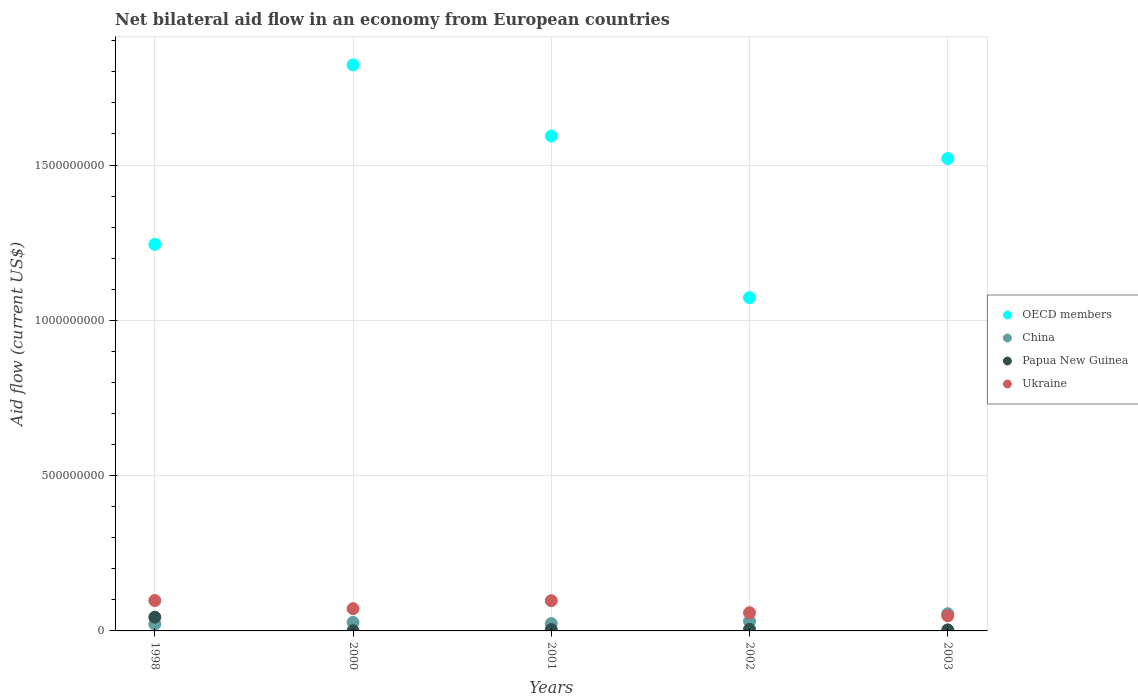How many different coloured dotlines are there?
Keep it short and to the point. 4. What is the net bilateral aid flow in Papua New Guinea in 2003?
Your response must be concise. 3.27e+06. Across all years, what is the maximum net bilateral aid flow in Papua New Guinea?
Provide a succinct answer. 4.43e+07. Across all years, what is the minimum net bilateral aid flow in Papua New Guinea?
Ensure brevity in your answer.  5.70e+05. In which year was the net bilateral aid flow in Papua New Guinea maximum?
Ensure brevity in your answer.  1998. In which year was the net bilateral aid flow in Papua New Guinea minimum?
Provide a succinct answer. 2000. What is the total net bilateral aid flow in OECD members in the graph?
Offer a very short reply. 7.25e+09. What is the difference between the net bilateral aid flow in Papua New Guinea in 2000 and that in 2001?
Your answer should be very brief. -3.73e+06. What is the difference between the net bilateral aid flow in Papua New Guinea in 1998 and the net bilateral aid flow in China in 2003?
Your answer should be compact. -1.11e+07. What is the average net bilateral aid flow in Papua New Guinea per year?
Your answer should be very brief. 1.15e+07. In the year 1998, what is the difference between the net bilateral aid flow in Ukraine and net bilateral aid flow in Papua New Guinea?
Ensure brevity in your answer.  5.36e+07. In how many years, is the net bilateral aid flow in China greater than 1600000000 US$?
Provide a succinct answer. 0. What is the ratio of the net bilateral aid flow in Papua New Guinea in 2000 to that in 2003?
Keep it short and to the point. 0.17. Is the net bilateral aid flow in OECD members in 1998 less than that in 2002?
Keep it short and to the point. No. Is the difference between the net bilateral aid flow in Ukraine in 2000 and 2003 greater than the difference between the net bilateral aid flow in Papua New Guinea in 2000 and 2003?
Provide a succinct answer. Yes. What is the difference between the highest and the lowest net bilateral aid flow in Papua New Guinea?
Your answer should be compact. 4.37e+07. In how many years, is the net bilateral aid flow in Papua New Guinea greater than the average net bilateral aid flow in Papua New Guinea taken over all years?
Make the answer very short. 1. Is it the case that in every year, the sum of the net bilateral aid flow in China and net bilateral aid flow in Ukraine  is greater than the sum of net bilateral aid flow in Papua New Guinea and net bilateral aid flow in OECD members?
Ensure brevity in your answer.  Yes. Is it the case that in every year, the sum of the net bilateral aid flow in OECD members and net bilateral aid flow in Ukraine  is greater than the net bilateral aid flow in China?
Provide a short and direct response. Yes. Does the net bilateral aid flow in Ukraine monotonically increase over the years?
Provide a succinct answer. No. Is the net bilateral aid flow in Ukraine strictly less than the net bilateral aid flow in Papua New Guinea over the years?
Provide a short and direct response. No. How many dotlines are there?
Provide a succinct answer. 4. What is the difference between two consecutive major ticks on the Y-axis?
Provide a short and direct response. 5.00e+08. Are the values on the major ticks of Y-axis written in scientific E-notation?
Give a very brief answer. No. Does the graph contain any zero values?
Your answer should be compact. No. Does the graph contain grids?
Your answer should be compact. Yes. How are the legend labels stacked?
Give a very brief answer. Vertical. What is the title of the graph?
Give a very brief answer. Net bilateral aid flow in an economy from European countries. What is the Aid flow (current US$) of OECD members in 1998?
Keep it short and to the point. 1.24e+09. What is the Aid flow (current US$) in China in 1998?
Ensure brevity in your answer.  2.17e+07. What is the Aid flow (current US$) of Papua New Guinea in 1998?
Offer a very short reply. 4.43e+07. What is the Aid flow (current US$) in Ukraine in 1998?
Make the answer very short. 9.78e+07. What is the Aid flow (current US$) in OECD members in 2000?
Provide a succinct answer. 1.82e+09. What is the Aid flow (current US$) of China in 2000?
Keep it short and to the point. 2.74e+07. What is the Aid flow (current US$) in Papua New Guinea in 2000?
Offer a very short reply. 5.70e+05. What is the Aid flow (current US$) of Ukraine in 2000?
Offer a terse response. 7.16e+07. What is the Aid flow (current US$) in OECD members in 2001?
Your answer should be very brief. 1.59e+09. What is the Aid flow (current US$) of China in 2001?
Provide a succinct answer. 2.36e+07. What is the Aid flow (current US$) in Papua New Guinea in 2001?
Keep it short and to the point. 4.30e+06. What is the Aid flow (current US$) in Ukraine in 2001?
Ensure brevity in your answer.  9.74e+07. What is the Aid flow (current US$) in OECD members in 2002?
Make the answer very short. 1.07e+09. What is the Aid flow (current US$) in China in 2002?
Offer a terse response. 3.11e+07. What is the Aid flow (current US$) of Papua New Guinea in 2002?
Provide a succinct answer. 4.86e+06. What is the Aid flow (current US$) of Ukraine in 2002?
Provide a succinct answer. 5.85e+07. What is the Aid flow (current US$) in OECD members in 2003?
Your answer should be compact. 1.52e+09. What is the Aid flow (current US$) in China in 2003?
Provide a short and direct response. 5.54e+07. What is the Aid flow (current US$) in Papua New Guinea in 2003?
Provide a succinct answer. 3.27e+06. What is the Aid flow (current US$) in Ukraine in 2003?
Ensure brevity in your answer.  4.86e+07. Across all years, what is the maximum Aid flow (current US$) of OECD members?
Make the answer very short. 1.82e+09. Across all years, what is the maximum Aid flow (current US$) of China?
Your response must be concise. 5.54e+07. Across all years, what is the maximum Aid flow (current US$) of Papua New Guinea?
Offer a very short reply. 4.43e+07. Across all years, what is the maximum Aid flow (current US$) of Ukraine?
Provide a short and direct response. 9.78e+07. Across all years, what is the minimum Aid flow (current US$) in OECD members?
Provide a succinct answer. 1.07e+09. Across all years, what is the minimum Aid flow (current US$) of China?
Keep it short and to the point. 2.17e+07. Across all years, what is the minimum Aid flow (current US$) in Papua New Guinea?
Your response must be concise. 5.70e+05. Across all years, what is the minimum Aid flow (current US$) in Ukraine?
Your response must be concise. 4.86e+07. What is the total Aid flow (current US$) of OECD members in the graph?
Ensure brevity in your answer.  7.25e+09. What is the total Aid flow (current US$) in China in the graph?
Ensure brevity in your answer.  1.59e+08. What is the total Aid flow (current US$) in Papua New Guinea in the graph?
Give a very brief answer. 5.73e+07. What is the total Aid flow (current US$) in Ukraine in the graph?
Provide a short and direct response. 3.74e+08. What is the difference between the Aid flow (current US$) of OECD members in 1998 and that in 2000?
Your response must be concise. -5.78e+08. What is the difference between the Aid flow (current US$) of China in 1998 and that in 2000?
Provide a short and direct response. -5.71e+06. What is the difference between the Aid flow (current US$) of Papua New Guinea in 1998 and that in 2000?
Offer a very short reply. 4.37e+07. What is the difference between the Aid flow (current US$) in Ukraine in 1998 and that in 2000?
Your response must be concise. 2.62e+07. What is the difference between the Aid flow (current US$) of OECD members in 1998 and that in 2001?
Offer a terse response. -3.49e+08. What is the difference between the Aid flow (current US$) in China in 1998 and that in 2001?
Make the answer very short. -1.91e+06. What is the difference between the Aid flow (current US$) of Papua New Guinea in 1998 and that in 2001?
Make the answer very short. 4.00e+07. What is the difference between the Aid flow (current US$) of Ukraine in 1998 and that in 2001?
Keep it short and to the point. 4.70e+05. What is the difference between the Aid flow (current US$) of OECD members in 1998 and that in 2002?
Provide a succinct answer. 1.72e+08. What is the difference between the Aid flow (current US$) in China in 1998 and that in 2002?
Keep it short and to the point. -9.41e+06. What is the difference between the Aid flow (current US$) of Papua New Guinea in 1998 and that in 2002?
Your answer should be compact. 3.94e+07. What is the difference between the Aid flow (current US$) in Ukraine in 1998 and that in 2002?
Your answer should be very brief. 3.93e+07. What is the difference between the Aid flow (current US$) in OECD members in 1998 and that in 2003?
Your answer should be compact. -2.76e+08. What is the difference between the Aid flow (current US$) in China in 1998 and that in 2003?
Provide a succinct answer. -3.36e+07. What is the difference between the Aid flow (current US$) in Papua New Guinea in 1998 and that in 2003?
Keep it short and to the point. 4.10e+07. What is the difference between the Aid flow (current US$) in Ukraine in 1998 and that in 2003?
Your answer should be compact. 4.92e+07. What is the difference between the Aid flow (current US$) in OECD members in 2000 and that in 2001?
Offer a terse response. 2.29e+08. What is the difference between the Aid flow (current US$) of China in 2000 and that in 2001?
Provide a short and direct response. 3.80e+06. What is the difference between the Aid flow (current US$) in Papua New Guinea in 2000 and that in 2001?
Ensure brevity in your answer.  -3.73e+06. What is the difference between the Aid flow (current US$) of Ukraine in 2000 and that in 2001?
Offer a very short reply. -2.57e+07. What is the difference between the Aid flow (current US$) of OECD members in 2000 and that in 2002?
Ensure brevity in your answer.  7.49e+08. What is the difference between the Aid flow (current US$) of China in 2000 and that in 2002?
Provide a succinct answer. -3.70e+06. What is the difference between the Aid flow (current US$) of Papua New Guinea in 2000 and that in 2002?
Ensure brevity in your answer.  -4.29e+06. What is the difference between the Aid flow (current US$) of Ukraine in 2000 and that in 2002?
Keep it short and to the point. 1.31e+07. What is the difference between the Aid flow (current US$) of OECD members in 2000 and that in 2003?
Make the answer very short. 3.02e+08. What is the difference between the Aid flow (current US$) of China in 2000 and that in 2003?
Ensure brevity in your answer.  -2.79e+07. What is the difference between the Aid flow (current US$) in Papua New Guinea in 2000 and that in 2003?
Your answer should be compact. -2.70e+06. What is the difference between the Aid flow (current US$) in Ukraine in 2000 and that in 2003?
Offer a very short reply. 2.30e+07. What is the difference between the Aid flow (current US$) in OECD members in 2001 and that in 2002?
Your answer should be very brief. 5.20e+08. What is the difference between the Aid flow (current US$) in China in 2001 and that in 2002?
Offer a very short reply. -7.50e+06. What is the difference between the Aid flow (current US$) in Papua New Guinea in 2001 and that in 2002?
Give a very brief answer. -5.60e+05. What is the difference between the Aid flow (current US$) in Ukraine in 2001 and that in 2002?
Offer a terse response. 3.88e+07. What is the difference between the Aid flow (current US$) of OECD members in 2001 and that in 2003?
Provide a succinct answer. 7.25e+07. What is the difference between the Aid flow (current US$) in China in 2001 and that in 2003?
Give a very brief answer. -3.17e+07. What is the difference between the Aid flow (current US$) of Papua New Guinea in 2001 and that in 2003?
Make the answer very short. 1.03e+06. What is the difference between the Aid flow (current US$) of Ukraine in 2001 and that in 2003?
Your answer should be compact. 4.87e+07. What is the difference between the Aid flow (current US$) of OECD members in 2002 and that in 2003?
Provide a short and direct response. -4.48e+08. What is the difference between the Aid flow (current US$) of China in 2002 and that in 2003?
Your response must be concise. -2.42e+07. What is the difference between the Aid flow (current US$) in Papua New Guinea in 2002 and that in 2003?
Offer a terse response. 1.59e+06. What is the difference between the Aid flow (current US$) of Ukraine in 2002 and that in 2003?
Give a very brief answer. 9.89e+06. What is the difference between the Aid flow (current US$) of OECD members in 1998 and the Aid flow (current US$) of China in 2000?
Provide a short and direct response. 1.22e+09. What is the difference between the Aid flow (current US$) of OECD members in 1998 and the Aid flow (current US$) of Papua New Guinea in 2000?
Your answer should be compact. 1.24e+09. What is the difference between the Aid flow (current US$) of OECD members in 1998 and the Aid flow (current US$) of Ukraine in 2000?
Keep it short and to the point. 1.17e+09. What is the difference between the Aid flow (current US$) in China in 1998 and the Aid flow (current US$) in Papua New Guinea in 2000?
Provide a succinct answer. 2.12e+07. What is the difference between the Aid flow (current US$) in China in 1998 and the Aid flow (current US$) in Ukraine in 2000?
Your answer should be compact. -4.99e+07. What is the difference between the Aid flow (current US$) of Papua New Guinea in 1998 and the Aid flow (current US$) of Ukraine in 2000?
Your answer should be compact. -2.74e+07. What is the difference between the Aid flow (current US$) of OECD members in 1998 and the Aid flow (current US$) of China in 2001?
Make the answer very short. 1.22e+09. What is the difference between the Aid flow (current US$) in OECD members in 1998 and the Aid flow (current US$) in Papua New Guinea in 2001?
Your response must be concise. 1.24e+09. What is the difference between the Aid flow (current US$) of OECD members in 1998 and the Aid flow (current US$) of Ukraine in 2001?
Provide a succinct answer. 1.15e+09. What is the difference between the Aid flow (current US$) of China in 1998 and the Aid flow (current US$) of Papua New Guinea in 2001?
Ensure brevity in your answer.  1.74e+07. What is the difference between the Aid flow (current US$) in China in 1998 and the Aid flow (current US$) in Ukraine in 2001?
Your answer should be very brief. -7.56e+07. What is the difference between the Aid flow (current US$) in Papua New Guinea in 1998 and the Aid flow (current US$) in Ukraine in 2001?
Offer a terse response. -5.31e+07. What is the difference between the Aid flow (current US$) in OECD members in 1998 and the Aid flow (current US$) in China in 2002?
Make the answer very short. 1.21e+09. What is the difference between the Aid flow (current US$) in OECD members in 1998 and the Aid flow (current US$) in Papua New Guinea in 2002?
Ensure brevity in your answer.  1.24e+09. What is the difference between the Aid flow (current US$) in OECD members in 1998 and the Aid flow (current US$) in Ukraine in 2002?
Ensure brevity in your answer.  1.19e+09. What is the difference between the Aid flow (current US$) of China in 1998 and the Aid flow (current US$) of Papua New Guinea in 2002?
Keep it short and to the point. 1.69e+07. What is the difference between the Aid flow (current US$) in China in 1998 and the Aid flow (current US$) in Ukraine in 2002?
Give a very brief answer. -3.68e+07. What is the difference between the Aid flow (current US$) in Papua New Guinea in 1998 and the Aid flow (current US$) in Ukraine in 2002?
Provide a short and direct response. -1.42e+07. What is the difference between the Aid flow (current US$) of OECD members in 1998 and the Aid flow (current US$) of China in 2003?
Ensure brevity in your answer.  1.19e+09. What is the difference between the Aid flow (current US$) of OECD members in 1998 and the Aid flow (current US$) of Papua New Guinea in 2003?
Provide a succinct answer. 1.24e+09. What is the difference between the Aid flow (current US$) in OECD members in 1998 and the Aid flow (current US$) in Ukraine in 2003?
Give a very brief answer. 1.20e+09. What is the difference between the Aid flow (current US$) in China in 1998 and the Aid flow (current US$) in Papua New Guinea in 2003?
Your response must be concise. 1.85e+07. What is the difference between the Aid flow (current US$) of China in 1998 and the Aid flow (current US$) of Ukraine in 2003?
Keep it short and to the point. -2.69e+07. What is the difference between the Aid flow (current US$) of Papua New Guinea in 1998 and the Aid flow (current US$) of Ukraine in 2003?
Provide a succinct answer. -4.35e+06. What is the difference between the Aid flow (current US$) of OECD members in 2000 and the Aid flow (current US$) of China in 2001?
Make the answer very short. 1.80e+09. What is the difference between the Aid flow (current US$) of OECD members in 2000 and the Aid flow (current US$) of Papua New Guinea in 2001?
Offer a terse response. 1.82e+09. What is the difference between the Aid flow (current US$) in OECD members in 2000 and the Aid flow (current US$) in Ukraine in 2001?
Your answer should be compact. 1.73e+09. What is the difference between the Aid flow (current US$) in China in 2000 and the Aid flow (current US$) in Papua New Guinea in 2001?
Offer a very short reply. 2.31e+07. What is the difference between the Aid flow (current US$) of China in 2000 and the Aid flow (current US$) of Ukraine in 2001?
Your answer should be compact. -6.99e+07. What is the difference between the Aid flow (current US$) of Papua New Guinea in 2000 and the Aid flow (current US$) of Ukraine in 2001?
Make the answer very short. -9.68e+07. What is the difference between the Aid flow (current US$) of OECD members in 2000 and the Aid flow (current US$) of China in 2002?
Make the answer very short. 1.79e+09. What is the difference between the Aid flow (current US$) of OECD members in 2000 and the Aid flow (current US$) of Papua New Guinea in 2002?
Your response must be concise. 1.82e+09. What is the difference between the Aid flow (current US$) in OECD members in 2000 and the Aid flow (current US$) in Ukraine in 2002?
Offer a terse response. 1.76e+09. What is the difference between the Aid flow (current US$) of China in 2000 and the Aid flow (current US$) of Papua New Guinea in 2002?
Your answer should be very brief. 2.26e+07. What is the difference between the Aid flow (current US$) in China in 2000 and the Aid flow (current US$) in Ukraine in 2002?
Provide a succinct answer. -3.11e+07. What is the difference between the Aid flow (current US$) in Papua New Guinea in 2000 and the Aid flow (current US$) in Ukraine in 2002?
Make the answer very short. -5.79e+07. What is the difference between the Aid flow (current US$) of OECD members in 2000 and the Aid flow (current US$) of China in 2003?
Offer a very short reply. 1.77e+09. What is the difference between the Aid flow (current US$) of OECD members in 2000 and the Aid flow (current US$) of Papua New Guinea in 2003?
Ensure brevity in your answer.  1.82e+09. What is the difference between the Aid flow (current US$) in OECD members in 2000 and the Aid flow (current US$) in Ukraine in 2003?
Keep it short and to the point. 1.77e+09. What is the difference between the Aid flow (current US$) of China in 2000 and the Aid flow (current US$) of Papua New Guinea in 2003?
Give a very brief answer. 2.42e+07. What is the difference between the Aid flow (current US$) of China in 2000 and the Aid flow (current US$) of Ukraine in 2003?
Ensure brevity in your answer.  -2.12e+07. What is the difference between the Aid flow (current US$) in Papua New Guinea in 2000 and the Aid flow (current US$) in Ukraine in 2003?
Provide a succinct answer. -4.80e+07. What is the difference between the Aid flow (current US$) in OECD members in 2001 and the Aid flow (current US$) in China in 2002?
Provide a succinct answer. 1.56e+09. What is the difference between the Aid flow (current US$) of OECD members in 2001 and the Aid flow (current US$) of Papua New Guinea in 2002?
Offer a very short reply. 1.59e+09. What is the difference between the Aid flow (current US$) in OECD members in 2001 and the Aid flow (current US$) in Ukraine in 2002?
Your answer should be compact. 1.53e+09. What is the difference between the Aid flow (current US$) of China in 2001 and the Aid flow (current US$) of Papua New Guinea in 2002?
Give a very brief answer. 1.88e+07. What is the difference between the Aid flow (current US$) in China in 2001 and the Aid flow (current US$) in Ukraine in 2002?
Ensure brevity in your answer.  -3.49e+07. What is the difference between the Aid flow (current US$) of Papua New Guinea in 2001 and the Aid flow (current US$) of Ukraine in 2002?
Ensure brevity in your answer.  -5.42e+07. What is the difference between the Aid flow (current US$) in OECD members in 2001 and the Aid flow (current US$) in China in 2003?
Keep it short and to the point. 1.54e+09. What is the difference between the Aid flow (current US$) in OECD members in 2001 and the Aid flow (current US$) in Papua New Guinea in 2003?
Make the answer very short. 1.59e+09. What is the difference between the Aid flow (current US$) in OECD members in 2001 and the Aid flow (current US$) in Ukraine in 2003?
Give a very brief answer. 1.54e+09. What is the difference between the Aid flow (current US$) of China in 2001 and the Aid flow (current US$) of Papua New Guinea in 2003?
Provide a succinct answer. 2.04e+07. What is the difference between the Aid flow (current US$) of China in 2001 and the Aid flow (current US$) of Ukraine in 2003?
Your answer should be compact. -2.50e+07. What is the difference between the Aid flow (current US$) in Papua New Guinea in 2001 and the Aid flow (current US$) in Ukraine in 2003?
Make the answer very short. -4.43e+07. What is the difference between the Aid flow (current US$) in OECD members in 2002 and the Aid flow (current US$) in China in 2003?
Provide a short and direct response. 1.02e+09. What is the difference between the Aid flow (current US$) in OECD members in 2002 and the Aid flow (current US$) in Papua New Guinea in 2003?
Keep it short and to the point. 1.07e+09. What is the difference between the Aid flow (current US$) in OECD members in 2002 and the Aid flow (current US$) in Ukraine in 2003?
Offer a terse response. 1.02e+09. What is the difference between the Aid flow (current US$) of China in 2002 and the Aid flow (current US$) of Papua New Guinea in 2003?
Provide a succinct answer. 2.79e+07. What is the difference between the Aid flow (current US$) in China in 2002 and the Aid flow (current US$) in Ukraine in 2003?
Your answer should be very brief. -1.75e+07. What is the difference between the Aid flow (current US$) of Papua New Guinea in 2002 and the Aid flow (current US$) of Ukraine in 2003?
Your answer should be compact. -4.38e+07. What is the average Aid flow (current US$) in OECD members per year?
Keep it short and to the point. 1.45e+09. What is the average Aid flow (current US$) of China per year?
Give a very brief answer. 3.19e+07. What is the average Aid flow (current US$) in Papua New Guinea per year?
Offer a terse response. 1.15e+07. What is the average Aid flow (current US$) of Ukraine per year?
Provide a short and direct response. 7.48e+07. In the year 1998, what is the difference between the Aid flow (current US$) in OECD members and Aid flow (current US$) in China?
Your response must be concise. 1.22e+09. In the year 1998, what is the difference between the Aid flow (current US$) in OECD members and Aid flow (current US$) in Papua New Guinea?
Ensure brevity in your answer.  1.20e+09. In the year 1998, what is the difference between the Aid flow (current US$) in OECD members and Aid flow (current US$) in Ukraine?
Provide a short and direct response. 1.15e+09. In the year 1998, what is the difference between the Aid flow (current US$) of China and Aid flow (current US$) of Papua New Guinea?
Your response must be concise. -2.25e+07. In the year 1998, what is the difference between the Aid flow (current US$) in China and Aid flow (current US$) in Ukraine?
Your answer should be compact. -7.61e+07. In the year 1998, what is the difference between the Aid flow (current US$) of Papua New Guinea and Aid flow (current US$) of Ukraine?
Offer a terse response. -5.36e+07. In the year 2000, what is the difference between the Aid flow (current US$) in OECD members and Aid flow (current US$) in China?
Give a very brief answer. 1.79e+09. In the year 2000, what is the difference between the Aid flow (current US$) in OECD members and Aid flow (current US$) in Papua New Guinea?
Your response must be concise. 1.82e+09. In the year 2000, what is the difference between the Aid flow (current US$) of OECD members and Aid flow (current US$) of Ukraine?
Your response must be concise. 1.75e+09. In the year 2000, what is the difference between the Aid flow (current US$) in China and Aid flow (current US$) in Papua New Guinea?
Provide a short and direct response. 2.69e+07. In the year 2000, what is the difference between the Aid flow (current US$) in China and Aid flow (current US$) in Ukraine?
Your response must be concise. -4.42e+07. In the year 2000, what is the difference between the Aid flow (current US$) of Papua New Guinea and Aid flow (current US$) of Ukraine?
Make the answer very short. -7.11e+07. In the year 2001, what is the difference between the Aid flow (current US$) of OECD members and Aid flow (current US$) of China?
Offer a terse response. 1.57e+09. In the year 2001, what is the difference between the Aid flow (current US$) in OECD members and Aid flow (current US$) in Papua New Guinea?
Your response must be concise. 1.59e+09. In the year 2001, what is the difference between the Aid flow (current US$) in OECD members and Aid flow (current US$) in Ukraine?
Make the answer very short. 1.50e+09. In the year 2001, what is the difference between the Aid flow (current US$) of China and Aid flow (current US$) of Papua New Guinea?
Give a very brief answer. 1.93e+07. In the year 2001, what is the difference between the Aid flow (current US$) of China and Aid flow (current US$) of Ukraine?
Provide a short and direct response. -7.37e+07. In the year 2001, what is the difference between the Aid flow (current US$) in Papua New Guinea and Aid flow (current US$) in Ukraine?
Offer a very short reply. -9.30e+07. In the year 2002, what is the difference between the Aid flow (current US$) of OECD members and Aid flow (current US$) of China?
Offer a very short reply. 1.04e+09. In the year 2002, what is the difference between the Aid flow (current US$) in OECD members and Aid flow (current US$) in Papua New Guinea?
Keep it short and to the point. 1.07e+09. In the year 2002, what is the difference between the Aid flow (current US$) of OECD members and Aid flow (current US$) of Ukraine?
Offer a very short reply. 1.01e+09. In the year 2002, what is the difference between the Aid flow (current US$) in China and Aid flow (current US$) in Papua New Guinea?
Ensure brevity in your answer.  2.63e+07. In the year 2002, what is the difference between the Aid flow (current US$) in China and Aid flow (current US$) in Ukraine?
Offer a very short reply. -2.74e+07. In the year 2002, what is the difference between the Aid flow (current US$) in Papua New Guinea and Aid flow (current US$) in Ukraine?
Keep it short and to the point. -5.36e+07. In the year 2003, what is the difference between the Aid flow (current US$) of OECD members and Aid flow (current US$) of China?
Offer a very short reply. 1.47e+09. In the year 2003, what is the difference between the Aid flow (current US$) in OECD members and Aid flow (current US$) in Papua New Guinea?
Your response must be concise. 1.52e+09. In the year 2003, what is the difference between the Aid flow (current US$) of OECD members and Aid flow (current US$) of Ukraine?
Your response must be concise. 1.47e+09. In the year 2003, what is the difference between the Aid flow (current US$) in China and Aid flow (current US$) in Papua New Guinea?
Your answer should be very brief. 5.21e+07. In the year 2003, what is the difference between the Aid flow (current US$) of China and Aid flow (current US$) of Ukraine?
Ensure brevity in your answer.  6.76e+06. In the year 2003, what is the difference between the Aid flow (current US$) in Papua New Guinea and Aid flow (current US$) in Ukraine?
Your answer should be very brief. -4.54e+07. What is the ratio of the Aid flow (current US$) of OECD members in 1998 to that in 2000?
Ensure brevity in your answer.  0.68. What is the ratio of the Aid flow (current US$) of China in 1998 to that in 2000?
Keep it short and to the point. 0.79. What is the ratio of the Aid flow (current US$) of Papua New Guinea in 1998 to that in 2000?
Provide a short and direct response. 77.67. What is the ratio of the Aid flow (current US$) of Ukraine in 1998 to that in 2000?
Provide a succinct answer. 1.37. What is the ratio of the Aid flow (current US$) in OECD members in 1998 to that in 2001?
Provide a succinct answer. 0.78. What is the ratio of the Aid flow (current US$) of China in 1998 to that in 2001?
Your answer should be very brief. 0.92. What is the ratio of the Aid flow (current US$) of Papua New Guinea in 1998 to that in 2001?
Give a very brief answer. 10.3. What is the ratio of the Aid flow (current US$) in Ukraine in 1998 to that in 2001?
Offer a terse response. 1. What is the ratio of the Aid flow (current US$) of OECD members in 1998 to that in 2002?
Your answer should be compact. 1.16. What is the ratio of the Aid flow (current US$) in China in 1998 to that in 2002?
Give a very brief answer. 0.7. What is the ratio of the Aid flow (current US$) of Papua New Guinea in 1998 to that in 2002?
Your answer should be compact. 9.11. What is the ratio of the Aid flow (current US$) of Ukraine in 1998 to that in 2002?
Keep it short and to the point. 1.67. What is the ratio of the Aid flow (current US$) of OECD members in 1998 to that in 2003?
Make the answer very short. 0.82. What is the ratio of the Aid flow (current US$) of China in 1998 to that in 2003?
Provide a succinct answer. 0.39. What is the ratio of the Aid flow (current US$) in Papua New Guinea in 1998 to that in 2003?
Make the answer very short. 13.54. What is the ratio of the Aid flow (current US$) of Ukraine in 1998 to that in 2003?
Offer a terse response. 2.01. What is the ratio of the Aid flow (current US$) of OECD members in 2000 to that in 2001?
Ensure brevity in your answer.  1.14. What is the ratio of the Aid flow (current US$) of China in 2000 to that in 2001?
Your answer should be compact. 1.16. What is the ratio of the Aid flow (current US$) of Papua New Guinea in 2000 to that in 2001?
Provide a short and direct response. 0.13. What is the ratio of the Aid flow (current US$) of Ukraine in 2000 to that in 2001?
Your answer should be compact. 0.74. What is the ratio of the Aid flow (current US$) in OECD members in 2000 to that in 2002?
Give a very brief answer. 1.7. What is the ratio of the Aid flow (current US$) in China in 2000 to that in 2002?
Provide a short and direct response. 0.88. What is the ratio of the Aid flow (current US$) of Papua New Guinea in 2000 to that in 2002?
Offer a terse response. 0.12. What is the ratio of the Aid flow (current US$) in Ukraine in 2000 to that in 2002?
Your response must be concise. 1.22. What is the ratio of the Aid flow (current US$) in OECD members in 2000 to that in 2003?
Keep it short and to the point. 1.2. What is the ratio of the Aid flow (current US$) of China in 2000 to that in 2003?
Your response must be concise. 0.5. What is the ratio of the Aid flow (current US$) in Papua New Guinea in 2000 to that in 2003?
Offer a very short reply. 0.17. What is the ratio of the Aid flow (current US$) in Ukraine in 2000 to that in 2003?
Offer a very short reply. 1.47. What is the ratio of the Aid flow (current US$) of OECD members in 2001 to that in 2002?
Offer a very short reply. 1.48. What is the ratio of the Aid flow (current US$) of China in 2001 to that in 2002?
Offer a terse response. 0.76. What is the ratio of the Aid flow (current US$) in Papua New Guinea in 2001 to that in 2002?
Provide a succinct answer. 0.88. What is the ratio of the Aid flow (current US$) in Ukraine in 2001 to that in 2002?
Your answer should be very brief. 1.66. What is the ratio of the Aid flow (current US$) of OECD members in 2001 to that in 2003?
Ensure brevity in your answer.  1.05. What is the ratio of the Aid flow (current US$) of China in 2001 to that in 2003?
Provide a short and direct response. 0.43. What is the ratio of the Aid flow (current US$) in Papua New Guinea in 2001 to that in 2003?
Give a very brief answer. 1.31. What is the ratio of the Aid flow (current US$) of Ukraine in 2001 to that in 2003?
Make the answer very short. 2. What is the ratio of the Aid flow (current US$) of OECD members in 2002 to that in 2003?
Your answer should be very brief. 0.71. What is the ratio of the Aid flow (current US$) in China in 2002 to that in 2003?
Offer a very short reply. 0.56. What is the ratio of the Aid flow (current US$) of Papua New Guinea in 2002 to that in 2003?
Give a very brief answer. 1.49. What is the ratio of the Aid flow (current US$) in Ukraine in 2002 to that in 2003?
Make the answer very short. 1.2. What is the difference between the highest and the second highest Aid flow (current US$) of OECD members?
Offer a very short reply. 2.29e+08. What is the difference between the highest and the second highest Aid flow (current US$) of China?
Ensure brevity in your answer.  2.42e+07. What is the difference between the highest and the second highest Aid flow (current US$) in Papua New Guinea?
Your answer should be compact. 3.94e+07. What is the difference between the highest and the second highest Aid flow (current US$) of Ukraine?
Your response must be concise. 4.70e+05. What is the difference between the highest and the lowest Aid flow (current US$) of OECD members?
Offer a very short reply. 7.49e+08. What is the difference between the highest and the lowest Aid flow (current US$) in China?
Provide a succinct answer. 3.36e+07. What is the difference between the highest and the lowest Aid flow (current US$) of Papua New Guinea?
Make the answer very short. 4.37e+07. What is the difference between the highest and the lowest Aid flow (current US$) in Ukraine?
Make the answer very short. 4.92e+07. 